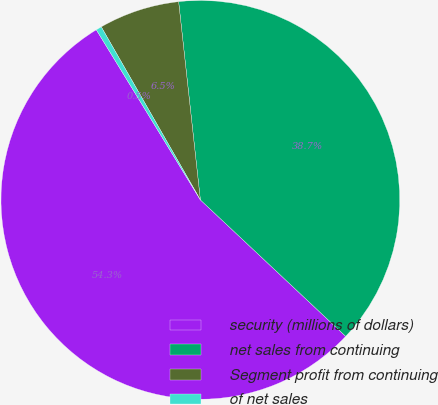Convert chart. <chart><loc_0><loc_0><loc_500><loc_500><pie_chart><fcel>security (millions of dollars)<fcel>net sales from continuing<fcel>Segment profit from continuing<fcel>of net sales<nl><fcel>54.26%<fcel>38.74%<fcel>6.54%<fcel>0.46%<nl></chart> 